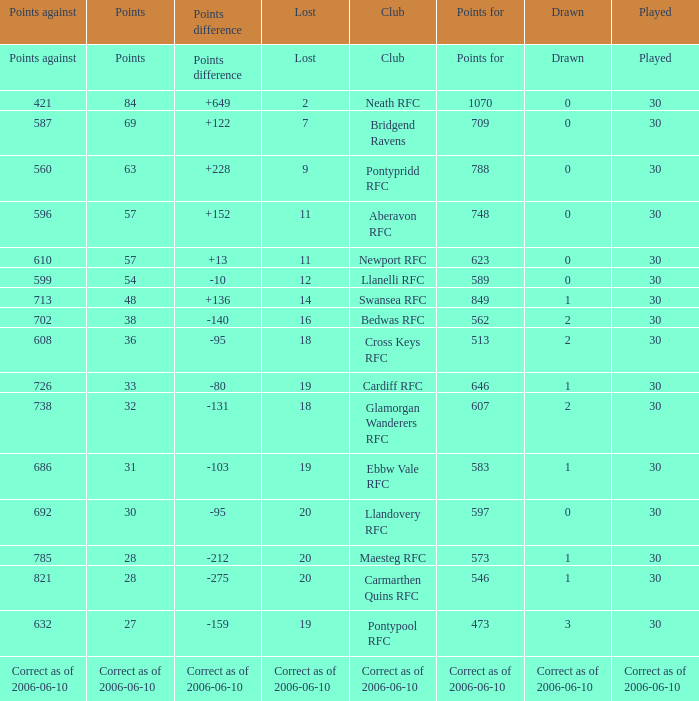What is Drawn, when Points Against is "686"? 1.0. 